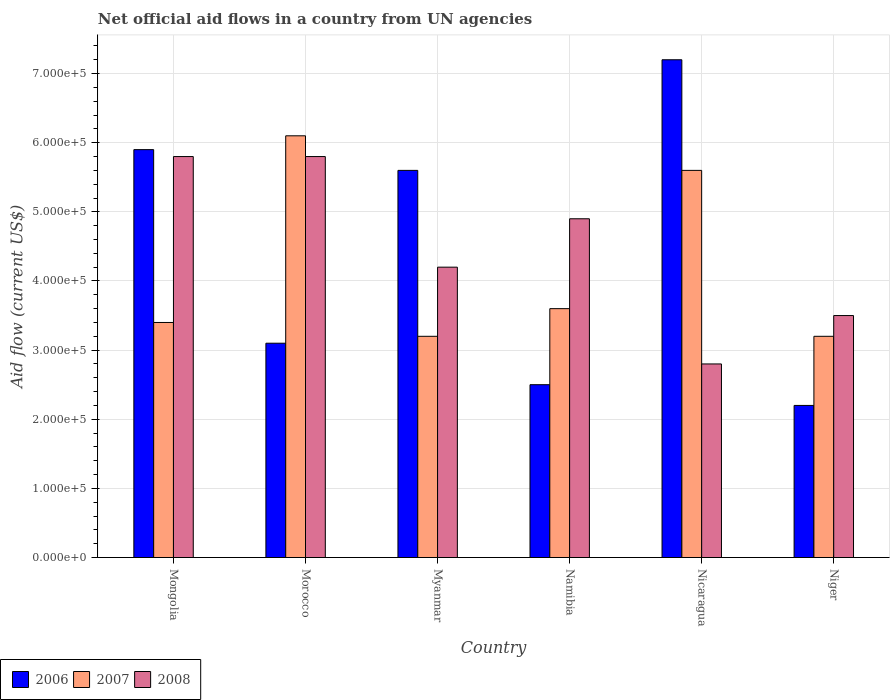How many different coloured bars are there?
Ensure brevity in your answer.  3. How many groups of bars are there?
Make the answer very short. 6. Are the number of bars on each tick of the X-axis equal?
Give a very brief answer. Yes. How many bars are there on the 5th tick from the left?
Ensure brevity in your answer.  3. How many bars are there on the 5th tick from the right?
Provide a short and direct response. 3. What is the label of the 5th group of bars from the left?
Keep it short and to the point. Nicaragua. Across all countries, what is the maximum net official aid flow in 2007?
Ensure brevity in your answer.  6.10e+05. In which country was the net official aid flow in 2007 maximum?
Make the answer very short. Morocco. In which country was the net official aid flow in 2008 minimum?
Make the answer very short. Nicaragua. What is the total net official aid flow in 2008 in the graph?
Your answer should be very brief. 2.70e+06. What is the difference between the net official aid flow in 2008 in Mongolia and that in Niger?
Your answer should be compact. 2.30e+05. What is the average net official aid flow in 2007 per country?
Your answer should be very brief. 4.18e+05. In how many countries, is the net official aid flow in 2008 greater than 240000 US$?
Provide a succinct answer. 6. What is the ratio of the net official aid flow in 2008 in Mongolia to that in Niger?
Ensure brevity in your answer.  1.66. Is the difference between the net official aid flow in 2007 in Myanmar and Niger greater than the difference between the net official aid flow in 2008 in Myanmar and Niger?
Your answer should be very brief. No. In how many countries, is the net official aid flow in 2008 greater than the average net official aid flow in 2008 taken over all countries?
Ensure brevity in your answer.  3. Is the sum of the net official aid flow in 2008 in Myanmar and Nicaragua greater than the maximum net official aid flow in 2007 across all countries?
Provide a succinct answer. Yes. What does the 1st bar from the left in Nicaragua represents?
Your answer should be compact. 2006. How many bars are there?
Make the answer very short. 18. Are all the bars in the graph horizontal?
Ensure brevity in your answer.  No. Are the values on the major ticks of Y-axis written in scientific E-notation?
Ensure brevity in your answer.  Yes. Where does the legend appear in the graph?
Offer a very short reply. Bottom left. How are the legend labels stacked?
Your answer should be compact. Horizontal. What is the title of the graph?
Provide a succinct answer. Net official aid flows in a country from UN agencies. Does "1981" appear as one of the legend labels in the graph?
Provide a short and direct response. No. What is the label or title of the X-axis?
Your answer should be very brief. Country. What is the label or title of the Y-axis?
Keep it short and to the point. Aid flow (current US$). What is the Aid flow (current US$) of 2006 in Mongolia?
Ensure brevity in your answer.  5.90e+05. What is the Aid flow (current US$) in 2007 in Mongolia?
Offer a terse response. 3.40e+05. What is the Aid flow (current US$) in 2008 in Mongolia?
Provide a short and direct response. 5.80e+05. What is the Aid flow (current US$) of 2006 in Morocco?
Your answer should be very brief. 3.10e+05. What is the Aid flow (current US$) in 2008 in Morocco?
Keep it short and to the point. 5.80e+05. What is the Aid flow (current US$) in 2006 in Myanmar?
Ensure brevity in your answer.  5.60e+05. What is the Aid flow (current US$) of 2007 in Myanmar?
Offer a terse response. 3.20e+05. What is the Aid flow (current US$) in 2008 in Myanmar?
Provide a short and direct response. 4.20e+05. What is the Aid flow (current US$) of 2006 in Namibia?
Offer a very short reply. 2.50e+05. What is the Aid flow (current US$) in 2007 in Namibia?
Keep it short and to the point. 3.60e+05. What is the Aid flow (current US$) of 2006 in Nicaragua?
Provide a short and direct response. 7.20e+05. What is the Aid flow (current US$) in 2007 in Nicaragua?
Ensure brevity in your answer.  5.60e+05. Across all countries, what is the maximum Aid flow (current US$) in 2006?
Provide a short and direct response. 7.20e+05. Across all countries, what is the maximum Aid flow (current US$) in 2008?
Give a very brief answer. 5.80e+05. Across all countries, what is the minimum Aid flow (current US$) of 2006?
Your answer should be compact. 2.20e+05. Across all countries, what is the minimum Aid flow (current US$) of 2007?
Your response must be concise. 3.20e+05. Across all countries, what is the minimum Aid flow (current US$) of 2008?
Keep it short and to the point. 2.80e+05. What is the total Aid flow (current US$) in 2006 in the graph?
Provide a succinct answer. 2.65e+06. What is the total Aid flow (current US$) of 2007 in the graph?
Offer a very short reply. 2.51e+06. What is the total Aid flow (current US$) of 2008 in the graph?
Your answer should be compact. 2.70e+06. What is the difference between the Aid flow (current US$) of 2006 in Mongolia and that in Morocco?
Provide a short and direct response. 2.80e+05. What is the difference between the Aid flow (current US$) of 2008 in Mongolia and that in Myanmar?
Offer a very short reply. 1.60e+05. What is the difference between the Aid flow (current US$) in 2008 in Mongolia and that in Namibia?
Your response must be concise. 9.00e+04. What is the difference between the Aid flow (current US$) of 2007 in Mongolia and that in Nicaragua?
Keep it short and to the point. -2.20e+05. What is the difference between the Aid flow (current US$) of 2007 in Mongolia and that in Niger?
Make the answer very short. 2.00e+04. What is the difference between the Aid flow (current US$) in 2006 in Morocco and that in Myanmar?
Provide a short and direct response. -2.50e+05. What is the difference between the Aid flow (current US$) of 2006 in Morocco and that in Nicaragua?
Your answer should be compact. -4.10e+05. What is the difference between the Aid flow (current US$) in 2007 in Morocco and that in Nicaragua?
Your answer should be very brief. 5.00e+04. What is the difference between the Aid flow (current US$) of 2008 in Morocco and that in Nicaragua?
Offer a very short reply. 3.00e+05. What is the difference between the Aid flow (current US$) in 2006 in Morocco and that in Niger?
Ensure brevity in your answer.  9.00e+04. What is the difference between the Aid flow (current US$) of 2008 in Myanmar and that in Nicaragua?
Your response must be concise. 1.40e+05. What is the difference between the Aid flow (current US$) in 2007 in Myanmar and that in Niger?
Your response must be concise. 0. What is the difference between the Aid flow (current US$) of 2008 in Myanmar and that in Niger?
Your answer should be compact. 7.00e+04. What is the difference between the Aid flow (current US$) in 2006 in Namibia and that in Nicaragua?
Offer a very short reply. -4.70e+05. What is the difference between the Aid flow (current US$) of 2007 in Namibia and that in Nicaragua?
Keep it short and to the point. -2.00e+05. What is the difference between the Aid flow (current US$) of 2006 in Namibia and that in Niger?
Ensure brevity in your answer.  3.00e+04. What is the difference between the Aid flow (current US$) in 2006 in Nicaragua and that in Niger?
Ensure brevity in your answer.  5.00e+05. What is the difference between the Aid flow (current US$) in 2007 in Nicaragua and that in Niger?
Your answer should be compact. 2.40e+05. What is the difference between the Aid flow (current US$) in 2008 in Nicaragua and that in Niger?
Your answer should be very brief. -7.00e+04. What is the difference between the Aid flow (current US$) in 2006 in Mongolia and the Aid flow (current US$) in 2007 in Morocco?
Give a very brief answer. -2.00e+04. What is the difference between the Aid flow (current US$) in 2007 in Mongolia and the Aid flow (current US$) in 2008 in Morocco?
Your answer should be very brief. -2.40e+05. What is the difference between the Aid flow (current US$) of 2006 in Mongolia and the Aid flow (current US$) of 2007 in Myanmar?
Your answer should be compact. 2.70e+05. What is the difference between the Aid flow (current US$) of 2006 in Mongolia and the Aid flow (current US$) of 2007 in Nicaragua?
Offer a very short reply. 3.00e+04. What is the difference between the Aid flow (current US$) in 2006 in Morocco and the Aid flow (current US$) in 2007 in Myanmar?
Provide a succinct answer. -10000. What is the difference between the Aid flow (current US$) of 2007 in Morocco and the Aid flow (current US$) of 2008 in Myanmar?
Your answer should be compact. 1.90e+05. What is the difference between the Aid flow (current US$) in 2006 in Morocco and the Aid flow (current US$) in 2007 in Namibia?
Provide a short and direct response. -5.00e+04. What is the difference between the Aid flow (current US$) in 2007 in Morocco and the Aid flow (current US$) in 2008 in Namibia?
Offer a very short reply. 1.20e+05. What is the difference between the Aid flow (current US$) of 2006 in Morocco and the Aid flow (current US$) of 2007 in Nicaragua?
Your answer should be compact. -2.50e+05. What is the difference between the Aid flow (current US$) in 2006 in Morocco and the Aid flow (current US$) in 2008 in Nicaragua?
Ensure brevity in your answer.  3.00e+04. What is the difference between the Aid flow (current US$) of 2006 in Morocco and the Aid flow (current US$) of 2007 in Niger?
Your answer should be very brief. -10000. What is the difference between the Aid flow (current US$) of 2007 in Morocco and the Aid flow (current US$) of 2008 in Niger?
Give a very brief answer. 2.60e+05. What is the difference between the Aid flow (current US$) in 2006 in Myanmar and the Aid flow (current US$) in 2008 in Namibia?
Your response must be concise. 7.00e+04. What is the difference between the Aid flow (current US$) of 2007 in Myanmar and the Aid flow (current US$) of 2008 in Namibia?
Make the answer very short. -1.70e+05. What is the difference between the Aid flow (current US$) of 2007 in Myanmar and the Aid flow (current US$) of 2008 in Nicaragua?
Provide a short and direct response. 4.00e+04. What is the difference between the Aid flow (current US$) in 2006 in Myanmar and the Aid flow (current US$) in 2007 in Niger?
Make the answer very short. 2.40e+05. What is the difference between the Aid flow (current US$) in 2006 in Myanmar and the Aid flow (current US$) in 2008 in Niger?
Offer a very short reply. 2.10e+05. What is the difference between the Aid flow (current US$) in 2007 in Myanmar and the Aid flow (current US$) in 2008 in Niger?
Give a very brief answer. -3.00e+04. What is the difference between the Aid flow (current US$) in 2006 in Namibia and the Aid flow (current US$) in 2007 in Nicaragua?
Your response must be concise. -3.10e+05. What is the difference between the Aid flow (current US$) of 2006 in Namibia and the Aid flow (current US$) of 2008 in Nicaragua?
Your response must be concise. -3.00e+04. What is the difference between the Aid flow (current US$) of 2007 in Namibia and the Aid flow (current US$) of 2008 in Niger?
Keep it short and to the point. 10000. What is the difference between the Aid flow (current US$) of 2007 in Nicaragua and the Aid flow (current US$) of 2008 in Niger?
Ensure brevity in your answer.  2.10e+05. What is the average Aid flow (current US$) of 2006 per country?
Your response must be concise. 4.42e+05. What is the average Aid flow (current US$) of 2007 per country?
Give a very brief answer. 4.18e+05. What is the average Aid flow (current US$) in 2008 per country?
Your answer should be compact. 4.50e+05. What is the difference between the Aid flow (current US$) of 2007 and Aid flow (current US$) of 2008 in Mongolia?
Ensure brevity in your answer.  -2.40e+05. What is the difference between the Aid flow (current US$) of 2006 and Aid flow (current US$) of 2007 in Morocco?
Keep it short and to the point. -3.00e+05. What is the difference between the Aid flow (current US$) of 2006 and Aid flow (current US$) of 2008 in Morocco?
Make the answer very short. -2.70e+05. What is the difference between the Aid flow (current US$) in 2006 and Aid flow (current US$) in 2007 in Myanmar?
Your response must be concise. 2.40e+05. What is the difference between the Aid flow (current US$) in 2006 and Aid flow (current US$) in 2008 in Namibia?
Your response must be concise. -2.40e+05. What is the difference between the Aid flow (current US$) in 2006 and Aid flow (current US$) in 2007 in Nicaragua?
Keep it short and to the point. 1.60e+05. What is the difference between the Aid flow (current US$) in 2006 and Aid flow (current US$) in 2008 in Nicaragua?
Give a very brief answer. 4.40e+05. What is the ratio of the Aid flow (current US$) of 2006 in Mongolia to that in Morocco?
Offer a terse response. 1.9. What is the ratio of the Aid flow (current US$) in 2007 in Mongolia to that in Morocco?
Make the answer very short. 0.56. What is the ratio of the Aid flow (current US$) in 2008 in Mongolia to that in Morocco?
Ensure brevity in your answer.  1. What is the ratio of the Aid flow (current US$) of 2006 in Mongolia to that in Myanmar?
Make the answer very short. 1.05. What is the ratio of the Aid flow (current US$) in 2007 in Mongolia to that in Myanmar?
Offer a very short reply. 1.06. What is the ratio of the Aid flow (current US$) in 2008 in Mongolia to that in Myanmar?
Your response must be concise. 1.38. What is the ratio of the Aid flow (current US$) of 2006 in Mongolia to that in Namibia?
Offer a terse response. 2.36. What is the ratio of the Aid flow (current US$) in 2007 in Mongolia to that in Namibia?
Offer a very short reply. 0.94. What is the ratio of the Aid flow (current US$) in 2008 in Mongolia to that in Namibia?
Your answer should be compact. 1.18. What is the ratio of the Aid flow (current US$) in 2006 in Mongolia to that in Nicaragua?
Ensure brevity in your answer.  0.82. What is the ratio of the Aid flow (current US$) in 2007 in Mongolia to that in Nicaragua?
Give a very brief answer. 0.61. What is the ratio of the Aid flow (current US$) of 2008 in Mongolia to that in Nicaragua?
Provide a short and direct response. 2.07. What is the ratio of the Aid flow (current US$) in 2006 in Mongolia to that in Niger?
Your response must be concise. 2.68. What is the ratio of the Aid flow (current US$) of 2008 in Mongolia to that in Niger?
Give a very brief answer. 1.66. What is the ratio of the Aid flow (current US$) of 2006 in Morocco to that in Myanmar?
Keep it short and to the point. 0.55. What is the ratio of the Aid flow (current US$) of 2007 in Morocco to that in Myanmar?
Provide a succinct answer. 1.91. What is the ratio of the Aid flow (current US$) of 2008 in Morocco to that in Myanmar?
Your response must be concise. 1.38. What is the ratio of the Aid flow (current US$) in 2006 in Morocco to that in Namibia?
Ensure brevity in your answer.  1.24. What is the ratio of the Aid flow (current US$) in 2007 in Morocco to that in Namibia?
Make the answer very short. 1.69. What is the ratio of the Aid flow (current US$) in 2008 in Morocco to that in Namibia?
Provide a succinct answer. 1.18. What is the ratio of the Aid flow (current US$) in 2006 in Morocco to that in Nicaragua?
Make the answer very short. 0.43. What is the ratio of the Aid flow (current US$) in 2007 in Morocco to that in Nicaragua?
Your response must be concise. 1.09. What is the ratio of the Aid flow (current US$) of 2008 in Morocco to that in Nicaragua?
Your response must be concise. 2.07. What is the ratio of the Aid flow (current US$) of 2006 in Morocco to that in Niger?
Provide a succinct answer. 1.41. What is the ratio of the Aid flow (current US$) in 2007 in Morocco to that in Niger?
Your answer should be very brief. 1.91. What is the ratio of the Aid flow (current US$) in 2008 in Morocco to that in Niger?
Offer a terse response. 1.66. What is the ratio of the Aid flow (current US$) in 2006 in Myanmar to that in Namibia?
Your response must be concise. 2.24. What is the ratio of the Aid flow (current US$) in 2007 in Myanmar to that in Namibia?
Give a very brief answer. 0.89. What is the ratio of the Aid flow (current US$) in 2008 in Myanmar to that in Namibia?
Your answer should be compact. 0.86. What is the ratio of the Aid flow (current US$) in 2006 in Myanmar to that in Nicaragua?
Your response must be concise. 0.78. What is the ratio of the Aid flow (current US$) of 2006 in Myanmar to that in Niger?
Your response must be concise. 2.55. What is the ratio of the Aid flow (current US$) of 2006 in Namibia to that in Nicaragua?
Your answer should be compact. 0.35. What is the ratio of the Aid flow (current US$) of 2007 in Namibia to that in Nicaragua?
Provide a succinct answer. 0.64. What is the ratio of the Aid flow (current US$) in 2008 in Namibia to that in Nicaragua?
Your answer should be compact. 1.75. What is the ratio of the Aid flow (current US$) of 2006 in Namibia to that in Niger?
Provide a succinct answer. 1.14. What is the ratio of the Aid flow (current US$) in 2008 in Namibia to that in Niger?
Your answer should be compact. 1.4. What is the ratio of the Aid flow (current US$) of 2006 in Nicaragua to that in Niger?
Your answer should be very brief. 3.27. What is the ratio of the Aid flow (current US$) of 2008 in Nicaragua to that in Niger?
Provide a succinct answer. 0.8. What is the difference between the highest and the second highest Aid flow (current US$) in 2008?
Your response must be concise. 0. What is the difference between the highest and the lowest Aid flow (current US$) of 2007?
Offer a terse response. 2.90e+05. What is the difference between the highest and the lowest Aid flow (current US$) of 2008?
Your answer should be very brief. 3.00e+05. 